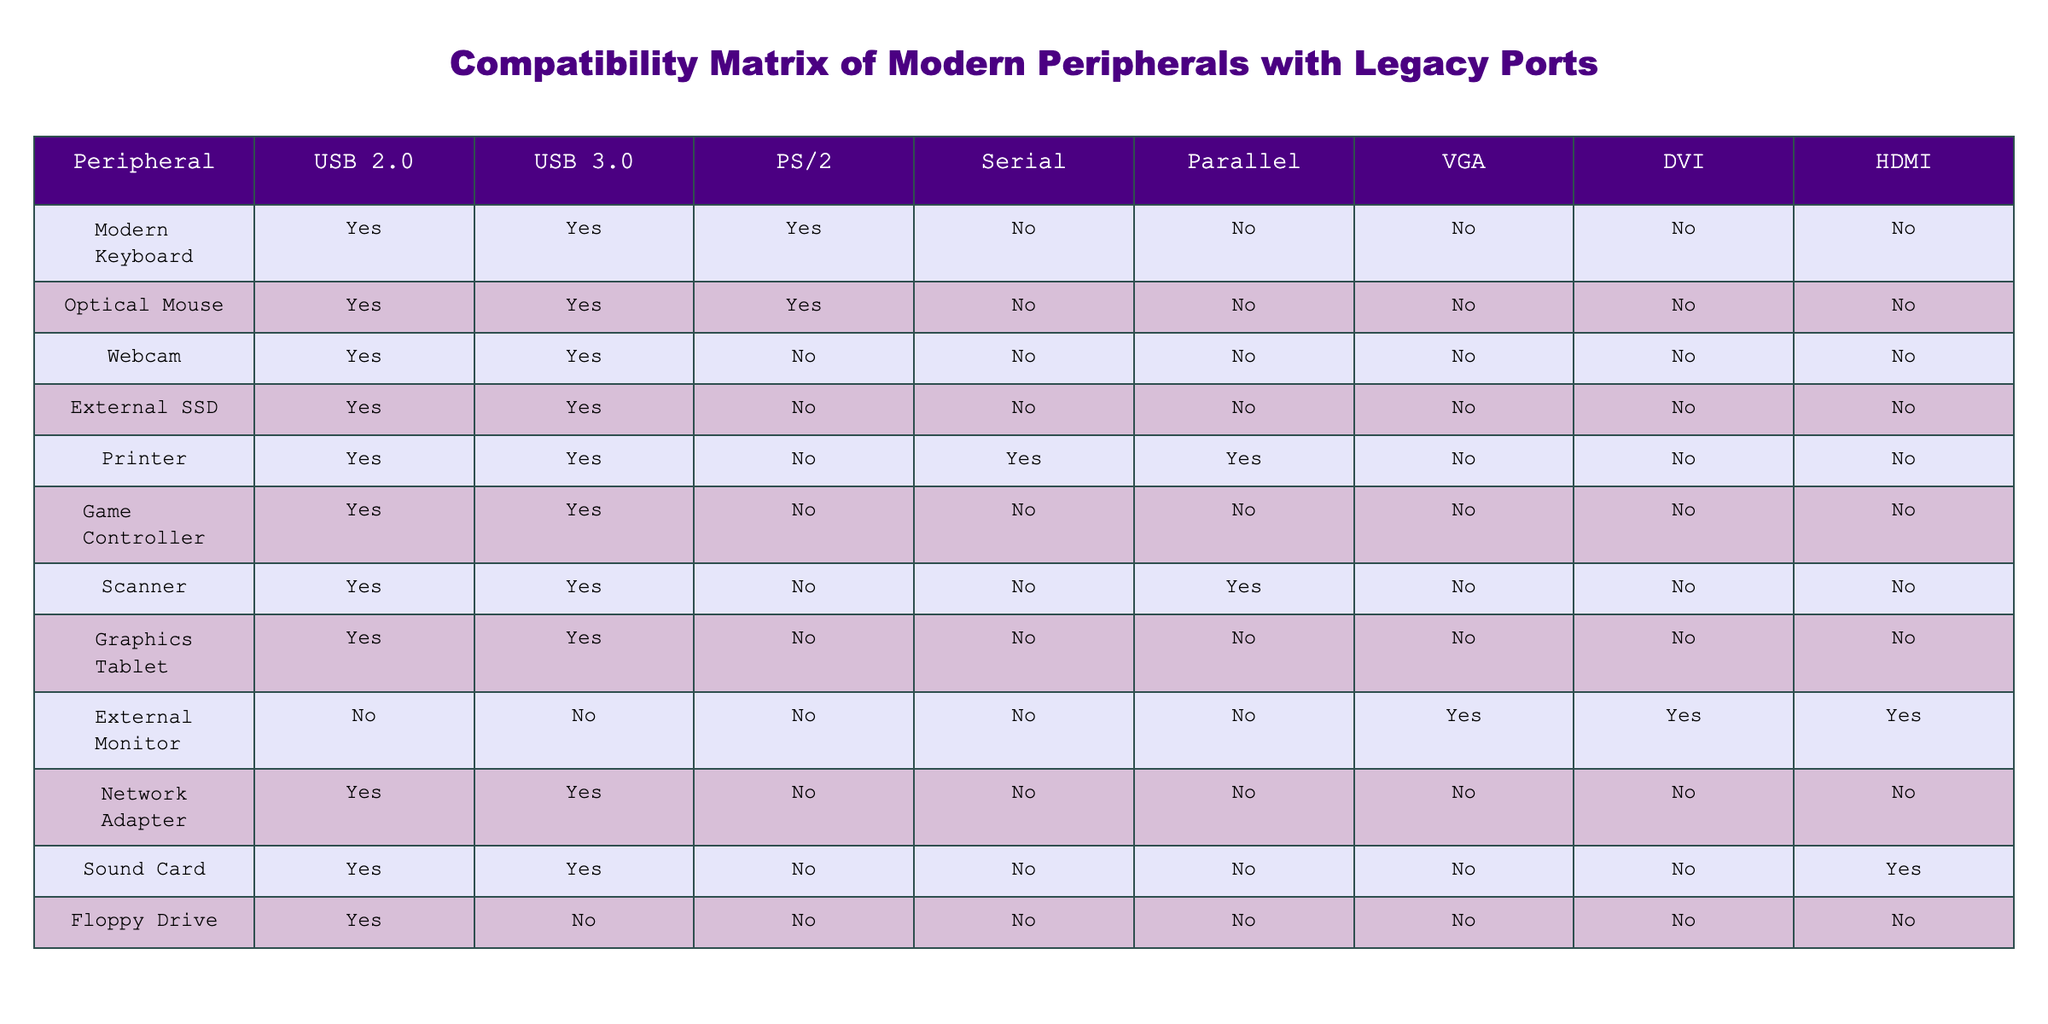What modern peripherals are compatible with USB 2.0? By checking the first column of the table, we can see that all peripherals except the External Monitor and the Sound Card are compatible with USB 2.0.
Answer: Modern Keyboard, Optical Mouse, Webcam, External SSD, Printer, Game Controller, Scanner, Graphics Tablet, Network Adapter, Floppy Drive How many peripherals are compatible with HDMI? We look within the HDMI column and find that only the External Monitor and the Sound Card are marked as compatible, giving us a total of 2 peripherals.
Answer: 2 Is the Printer compatible with Serial ports? We can see the corresponding cell under the Printer row and Serial column shows "Yes," indicating that the Printer does indeed have compatibility with Serial ports.
Answer: Yes Which peripherals are compatible with both USB 3.0 and PS/2? We first check the USB 3.0 column for "Yes" responses and then look at the same rows in the PS/2 column. This results in two peripherals: Modern Keyboard and Optical Mouse.
Answer: Modern Keyboard, Optical Mouse Are any peripherals compatible with Parallel ports? If so, which? By examining the Parallel column, we find that the Printer and Scanner have "Yes" checked, confirming their compatibility with Parallel ports.
Answer: Printer, Scanner How many peripherals are not compatible with any USB ports? We assess both USB 2.0 and USB 3.0 columns to find that the only peripheral not compatible with any USB ports is the External Monitor, which has "No" for both USB columns.
Answer: 1 What is the total number of peripherals that support VGA output? Looking at the VGA column, we find that only the External Monitor is compatible (as all other peripherals have "No"), leading us to conclude that there is just 1 peripheral.
Answer: 1 Which peripheral has the most compatibility across the various ports? By counting the "Yes" responses for each peripheral, we can determine that the Printer has the most compatibility, with a total of 4 ports (USB 2.0, USB 3.0, Serial, and Parallel).
Answer: Printer How many peripherals can connect to a monitor via DVI? When we check the DVI column, we see that only the External Monitor is compatible, thus only 1 peripheral can connect via DVI.
Answer: 1 Do all peripherals that support HDMI also support DVI? Upon examining the table, we find that the only peripheral that supports HDMI is the External Monitor, which indeed does support DVI. Thus, the statement is true.
Answer: Yes 